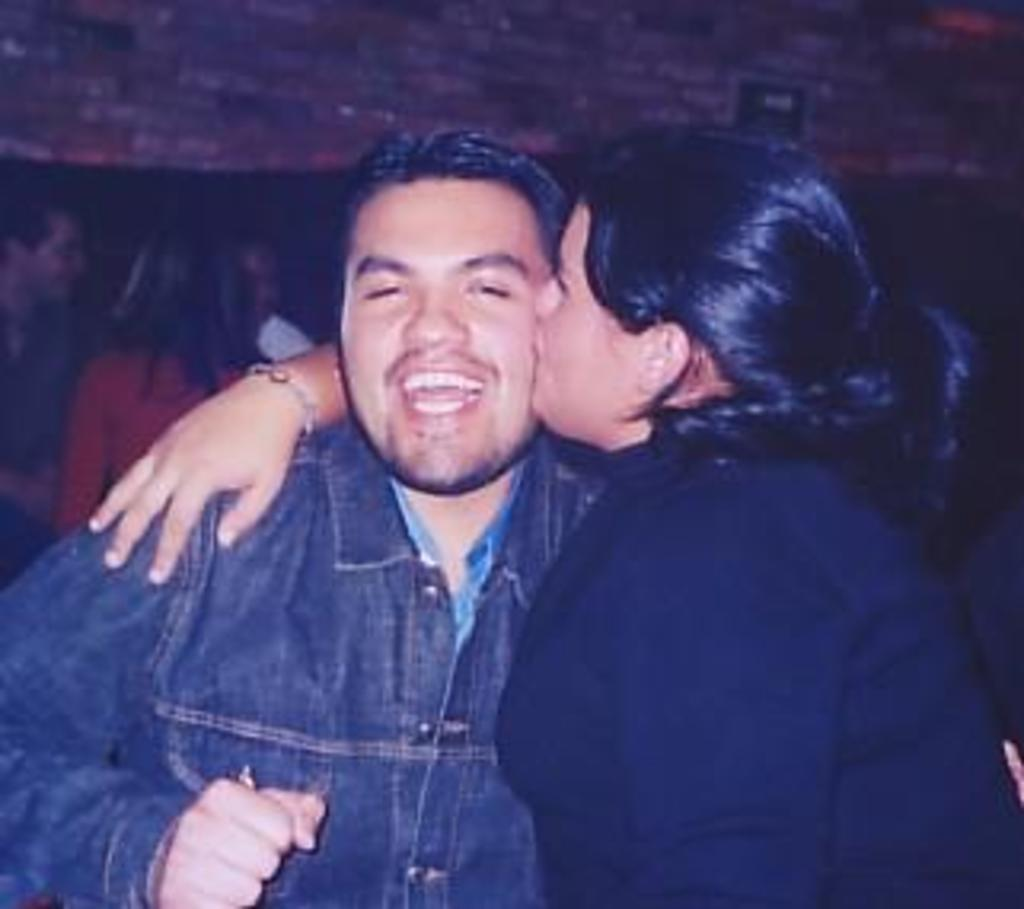Who is the main subject in the image? There is a woman in the image. What is the woman wearing? The woman is wearing a black dress. What is the woman doing in the image? The woman is kissing a man on the cheeks. Who is the man in front of the woman? There is a man in front of the woman. What can be seen in the background of the image? There are other persons in the background of the image. What type of cub is visible in the image? There is no cub present in the image. 